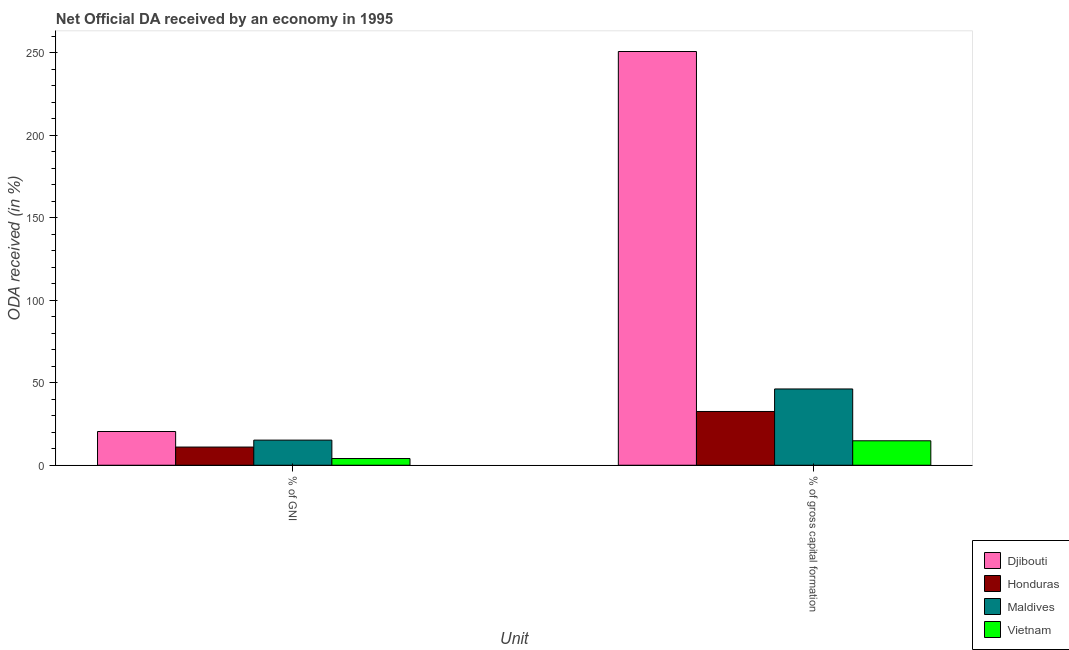How many different coloured bars are there?
Ensure brevity in your answer.  4. How many bars are there on the 2nd tick from the right?
Offer a very short reply. 4. What is the label of the 1st group of bars from the left?
Your answer should be compact. % of GNI. What is the oda received as percentage of gni in Maldives?
Give a very brief answer. 15.24. Across all countries, what is the maximum oda received as percentage of gni?
Make the answer very short. 20.46. Across all countries, what is the minimum oda received as percentage of gross capital formation?
Provide a succinct answer. 14.83. In which country was the oda received as percentage of gross capital formation maximum?
Offer a terse response. Djibouti. In which country was the oda received as percentage of gross capital formation minimum?
Offer a terse response. Vietnam. What is the total oda received as percentage of gni in the graph?
Provide a short and direct response. 50.79. What is the difference between the oda received as percentage of gross capital formation in Vietnam and that in Honduras?
Your response must be concise. -17.77. What is the difference between the oda received as percentage of gross capital formation in Maldives and the oda received as percentage of gni in Vietnam?
Your answer should be compact. 42.18. What is the average oda received as percentage of gni per country?
Keep it short and to the point. 12.7. What is the difference between the oda received as percentage of gross capital formation and oda received as percentage of gni in Honduras?
Provide a succinct answer. 21.57. What is the ratio of the oda received as percentage of gross capital formation in Djibouti to that in Vietnam?
Provide a succinct answer. 16.92. Is the oda received as percentage of gni in Djibouti less than that in Maldives?
Keep it short and to the point. No. In how many countries, is the oda received as percentage of gni greater than the average oda received as percentage of gni taken over all countries?
Make the answer very short. 2. What does the 1st bar from the left in % of GNI represents?
Offer a very short reply. Djibouti. What does the 4th bar from the right in % of gross capital formation represents?
Give a very brief answer. Djibouti. How many bars are there?
Keep it short and to the point. 8. How many countries are there in the graph?
Offer a terse response. 4. What is the difference between two consecutive major ticks on the Y-axis?
Offer a very short reply. 50. Does the graph contain any zero values?
Offer a very short reply. No. Does the graph contain grids?
Your answer should be compact. No. Where does the legend appear in the graph?
Offer a very short reply. Bottom right. How are the legend labels stacked?
Offer a terse response. Vertical. What is the title of the graph?
Your answer should be very brief. Net Official DA received by an economy in 1995. What is the label or title of the X-axis?
Make the answer very short. Unit. What is the label or title of the Y-axis?
Provide a short and direct response. ODA received (in %). What is the ODA received (in %) of Djibouti in % of GNI?
Your answer should be compact. 20.46. What is the ODA received (in %) in Honduras in % of GNI?
Provide a succinct answer. 11.03. What is the ODA received (in %) in Maldives in % of GNI?
Give a very brief answer. 15.24. What is the ODA received (in %) in Vietnam in % of GNI?
Your answer should be compact. 4.07. What is the ODA received (in %) of Djibouti in % of gross capital formation?
Ensure brevity in your answer.  250.89. What is the ODA received (in %) in Honduras in % of gross capital formation?
Your answer should be very brief. 32.6. What is the ODA received (in %) in Maldives in % of gross capital formation?
Ensure brevity in your answer.  46.26. What is the ODA received (in %) of Vietnam in % of gross capital formation?
Your answer should be compact. 14.83. Across all Unit, what is the maximum ODA received (in %) in Djibouti?
Make the answer very short. 250.89. Across all Unit, what is the maximum ODA received (in %) of Honduras?
Offer a very short reply. 32.6. Across all Unit, what is the maximum ODA received (in %) of Maldives?
Ensure brevity in your answer.  46.26. Across all Unit, what is the maximum ODA received (in %) in Vietnam?
Offer a terse response. 14.83. Across all Unit, what is the minimum ODA received (in %) in Djibouti?
Offer a very short reply. 20.46. Across all Unit, what is the minimum ODA received (in %) of Honduras?
Your response must be concise. 11.03. Across all Unit, what is the minimum ODA received (in %) of Maldives?
Ensure brevity in your answer.  15.24. Across all Unit, what is the minimum ODA received (in %) of Vietnam?
Offer a terse response. 4.07. What is the total ODA received (in %) in Djibouti in the graph?
Your answer should be very brief. 271.35. What is the total ODA received (in %) in Honduras in the graph?
Give a very brief answer. 43.63. What is the total ODA received (in %) of Maldives in the graph?
Give a very brief answer. 61.49. What is the total ODA received (in %) in Vietnam in the graph?
Provide a short and direct response. 18.9. What is the difference between the ODA received (in %) in Djibouti in % of GNI and that in % of gross capital formation?
Your answer should be compact. -230.43. What is the difference between the ODA received (in %) of Honduras in % of GNI and that in % of gross capital formation?
Make the answer very short. -21.57. What is the difference between the ODA received (in %) of Maldives in % of GNI and that in % of gross capital formation?
Your answer should be compact. -31.02. What is the difference between the ODA received (in %) of Vietnam in % of GNI and that in % of gross capital formation?
Make the answer very short. -10.76. What is the difference between the ODA received (in %) in Djibouti in % of GNI and the ODA received (in %) in Honduras in % of gross capital formation?
Ensure brevity in your answer.  -12.14. What is the difference between the ODA received (in %) in Djibouti in % of GNI and the ODA received (in %) in Maldives in % of gross capital formation?
Offer a terse response. -25.8. What is the difference between the ODA received (in %) in Djibouti in % of GNI and the ODA received (in %) in Vietnam in % of gross capital formation?
Give a very brief answer. 5.63. What is the difference between the ODA received (in %) in Honduras in % of GNI and the ODA received (in %) in Maldives in % of gross capital formation?
Offer a terse response. -35.23. What is the difference between the ODA received (in %) in Honduras in % of GNI and the ODA received (in %) in Vietnam in % of gross capital formation?
Provide a succinct answer. -3.8. What is the difference between the ODA received (in %) of Maldives in % of GNI and the ODA received (in %) of Vietnam in % of gross capital formation?
Make the answer very short. 0.41. What is the average ODA received (in %) in Djibouti per Unit?
Keep it short and to the point. 135.67. What is the average ODA received (in %) in Honduras per Unit?
Keep it short and to the point. 21.82. What is the average ODA received (in %) of Maldives per Unit?
Offer a very short reply. 30.75. What is the average ODA received (in %) of Vietnam per Unit?
Provide a short and direct response. 9.45. What is the difference between the ODA received (in %) of Djibouti and ODA received (in %) of Honduras in % of GNI?
Offer a very short reply. 9.43. What is the difference between the ODA received (in %) of Djibouti and ODA received (in %) of Maldives in % of GNI?
Your response must be concise. 5.22. What is the difference between the ODA received (in %) in Djibouti and ODA received (in %) in Vietnam in % of GNI?
Offer a terse response. 16.39. What is the difference between the ODA received (in %) of Honduras and ODA received (in %) of Maldives in % of GNI?
Ensure brevity in your answer.  -4.21. What is the difference between the ODA received (in %) of Honduras and ODA received (in %) of Vietnam in % of GNI?
Offer a very short reply. 6.96. What is the difference between the ODA received (in %) of Maldives and ODA received (in %) of Vietnam in % of GNI?
Provide a succinct answer. 11.17. What is the difference between the ODA received (in %) in Djibouti and ODA received (in %) in Honduras in % of gross capital formation?
Your answer should be compact. 218.28. What is the difference between the ODA received (in %) in Djibouti and ODA received (in %) in Maldives in % of gross capital formation?
Make the answer very short. 204.63. What is the difference between the ODA received (in %) of Djibouti and ODA received (in %) of Vietnam in % of gross capital formation?
Your answer should be compact. 236.06. What is the difference between the ODA received (in %) of Honduras and ODA received (in %) of Maldives in % of gross capital formation?
Offer a terse response. -13.65. What is the difference between the ODA received (in %) in Honduras and ODA received (in %) in Vietnam in % of gross capital formation?
Ensure brevity in your answer.  17.77. What is the difference between the ODA received (in %) of Maldives and ODA received (in %) of Vietnam in % of gross capital formation?
Give a very brief answer. 31.42. What is the ratio of the ODA received (in %) of Djibouti in % of GNI to that in % of gross capital formation?
Give a very brief answer. 0.08. What is the ratio of the ODA received (in %) of Honduras in % of GNI to that in % of gross capital formation?
Give a very brief answer. 0.34. What is the ratio of the ODA received (in %) of Maldives in % of GNI to that in % of gross capital formation?
Offer a terse response. 0.33. What is the ratio of the ODA received (in %) of Vietnam in % of GNI to that in % of gross capital formation?
Offer a terse response. 0.27. What is the difference between the highest and the second highest ODA received (in %) in Djibouti?
Offer a terse response. 230.43. What is the difference between the highest and the second highest ODA received (in %) in Honduras?
Provide a succinct answer. 21.57. What is the difference between the highest and the second highest ODA received (in %) in Maldives?
Your response must be concise. 31.02. What is the difference between the highest and the second highest ODA received (in %) of Vietnam?
Provide a succinct answer. 10.76. What is the difference between the highest and the lowest ODA received (in %) of Djibouti?
Provide a succinct answer. 230.43. What is the difference between the highest and the lowest ODA received (in %) of Honduras?
Your response must be concise. 21.57. What is the difference between the highest and the lowest ODA received (in %) of Maldives?
Give a very brief answer. 31.02. What is the difference between the highest and the lowest ODA received (in %) in Vietnam?
Provide a succinct answer. 10.76. 